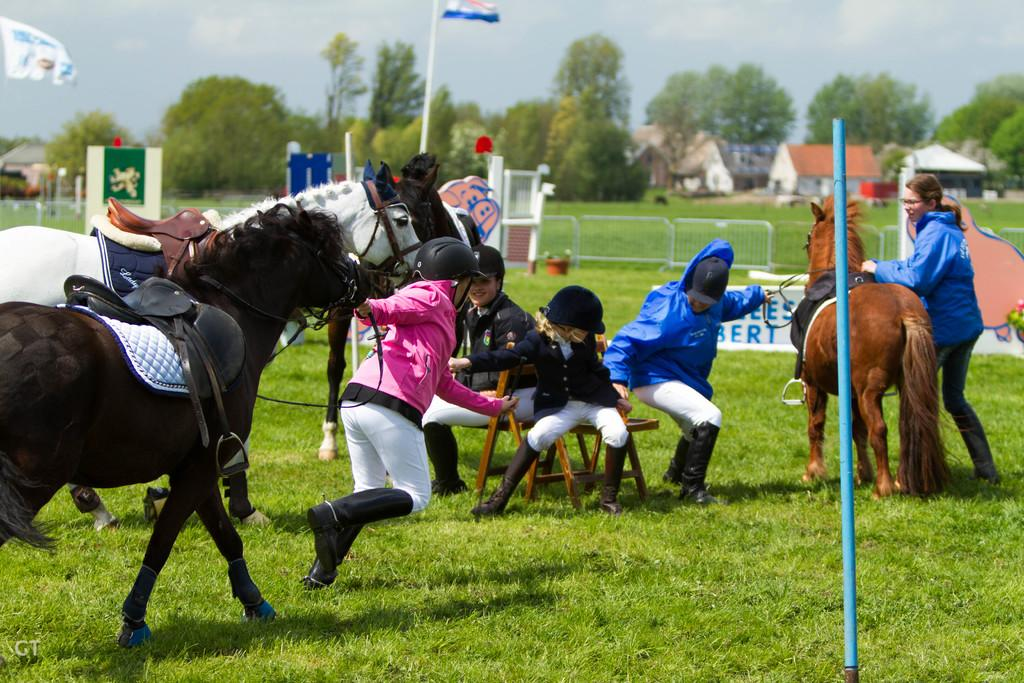What is the person in the image doing with the horse? The person is pulling a horse. Who else is interacting with the horse in the image? There is a woman holding a horse. What are the people in the chairs doing? The people are sitting in chairs on the grass. What can be seen in the background of the image? There are flags and a building visible in the background. What type of bat is hanging from the edge of the building in the image? There is no bat or edge of a building present in the image. 